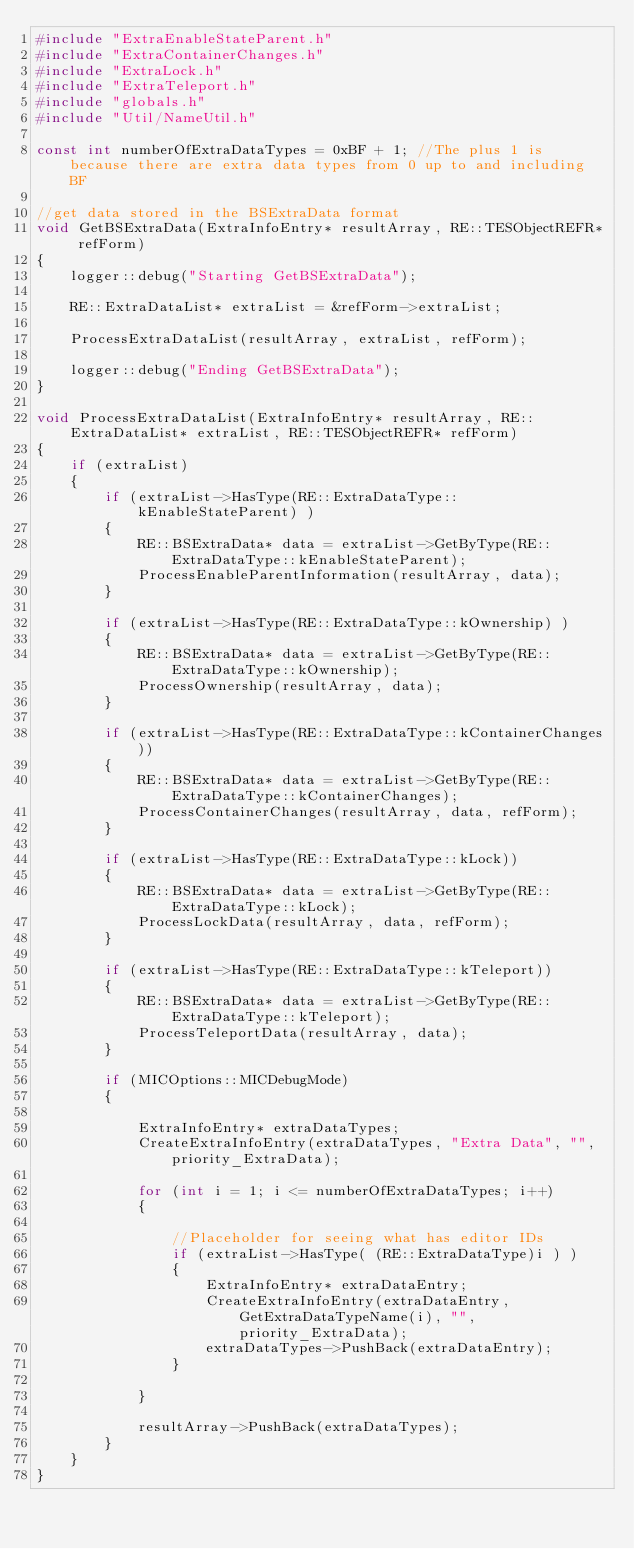Convert code to text. <code><loc_0><loc_0><loc_500><loc_500><_C++_>#include "ExtraEnableStateParent.h"
#include "ExtraContainerChanges.h"
#include "ExtraLock.h"
#include "ExtraTeleport.h"
#include "globals.h"
#include "Util/NameUtil.h"

const int numberOfExtraDataTypes = 0xBF + 1; //The plus 1 is because there are extra data types from 0 up to and including BF

//get data stored in the BSExtraData format
void GetBSExtraData(ExtraInfoEntry* resultArray, RE::TESObjectREFR* refForm)
{
	logger::debug("Starting GetBSExtraData");

	RE::ExtraDataList* extraList = &refForm->extraList;

	ProcessExtraDataList(resultArray, extraList, refForm);

	logger::debug("Ending GetBSExtraData");
}

void ProcessExtraDataList(ExtraInfoEntry* resultArray, RE::ExtraDataList* extraList, RE::TESObjectREFR* refForm)
{
	if (extraList)
	{
		if (extraList->HasType(RE::ExtraDataType::kEnableStateParent) )
		{
			RE::BSExtraData* data = extraList->GetByType(RE::ExtraDataType::kEnableStateParent);
			ProcessEnableParentInformation(resultArray, data);
		}

		if (extraList->HasType(RE::ExtraDataType::kOwnership) )
		{
			RE::BSExtraData* data = extraList->GetByType(RE::ExtraDataType::kOwnership);
			ProcessOwnership(resultArray, data);
		}

		if (extraList->HasType(RE::ExtraDataType::kContainerChanges))
		{
			RE::BSExtraData* data = extraList->GetByType(RE::ExtraDataType::kContainerChanges);
			ProcessContainerChanges(resultArray, data, refForm);
		}
		
		if (extraList->HasType(RE::ExtraDataType::kLock))
		{
			RE::BSExtraData* data = extraList->GetByType(RE::ExtraDataType::kLock);
			ProcessLockData(resultArray, data, refForm);
		}

		if (extraList->HasType(RE::ExtraDataType::kTeleport))
		{
			RE::BSExtraData* data = extraList->GetByType(RE::ExtraDataType::kTeleport);
			ProcessTeleportData(resultArray, data);
		}

		if (MICOptions::MICDebugMode)
		{
				
			ExtraInfoEntry* extraDataTypes;
			CreateExtraInfoEntry(extraDataTypes, "Extra Data", "", priority_ExtraData);

			for (int i = 1; i <= numberOfExtraDataTypes; i++)
			{

				//Placeholder for seeing what has editor IDs
				if (extraList->HasType( (RE::ExtraDataType)i ) )
				{
					ExtraInfoEntry* extraDataEntry;
					CreateExtraInfoEntry(extraDataEntry, GetExtraDataTypeName(i), "", priority_ExtraData);
					extraDataTypes->PushBack(extraDataEntry);
				}

			}

			resultArray->PushBack(extraDataTypes);
		}		
	}
}</code> 